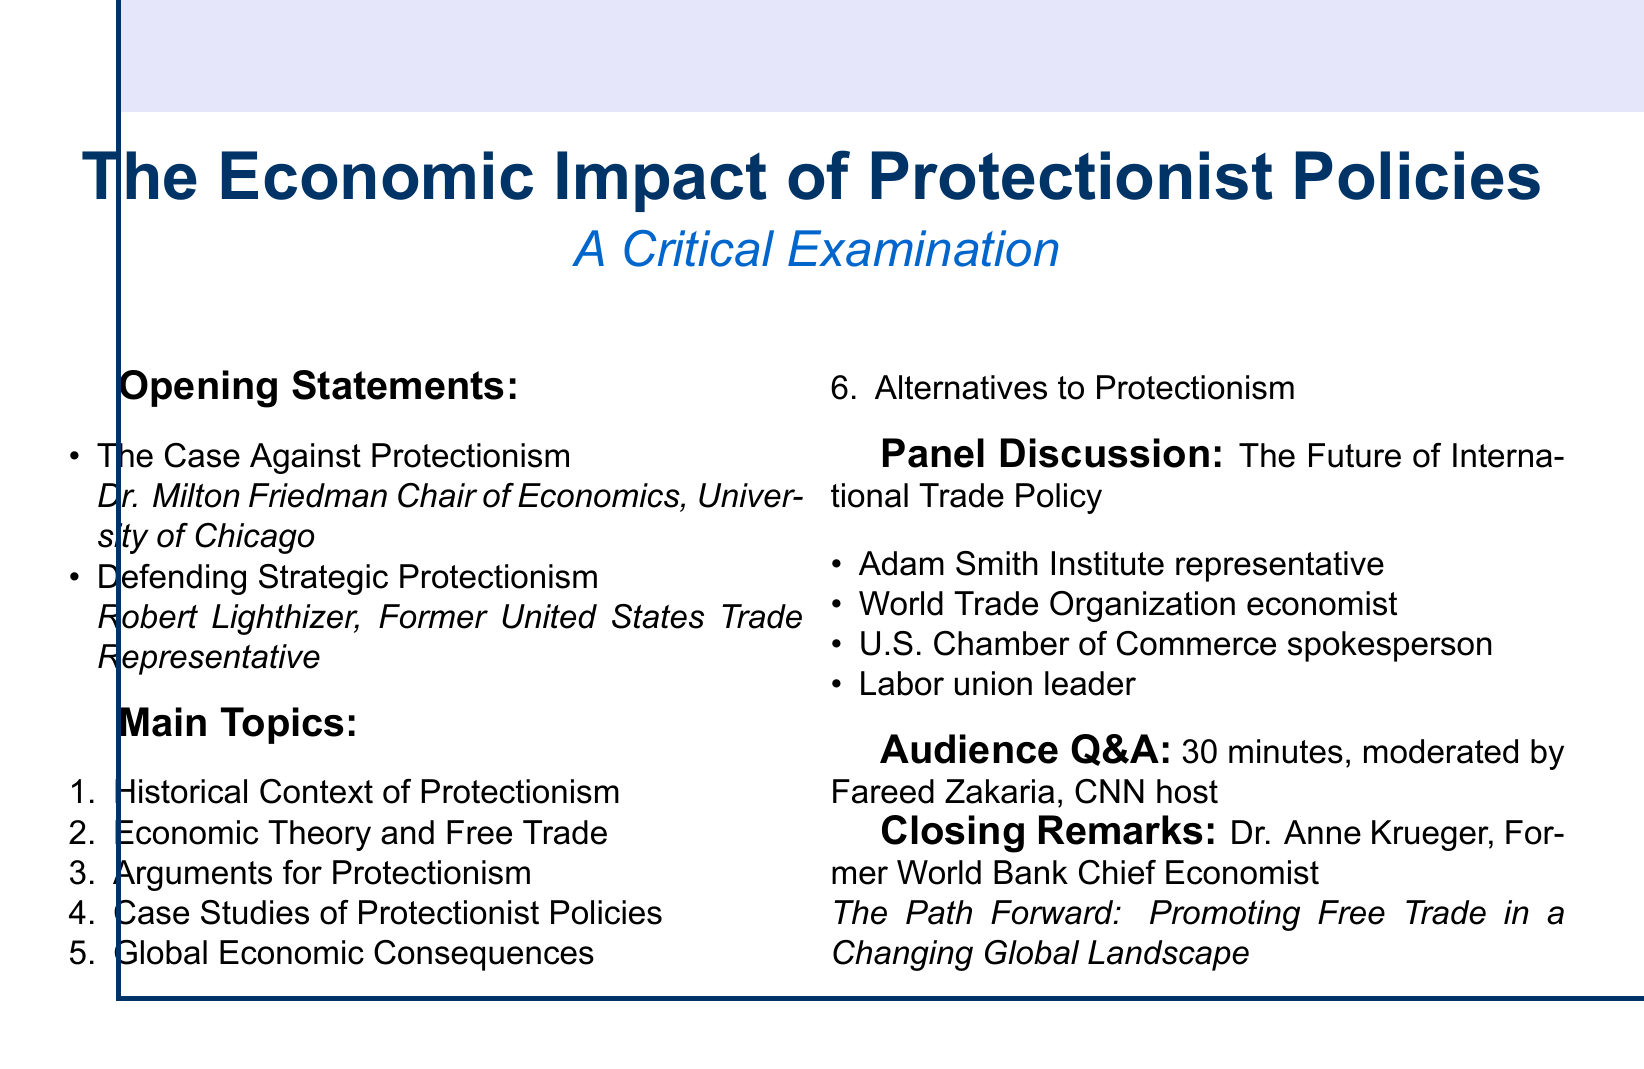What is the title of the debate? The title of the debate is specified at the beginning of the document, which highlights the topic of discussion.
Answer: The Economic Impact of Protectionist Policies: A Critical Examination Who is the speaker for "The Case Against Protectionism"? The document clearly lists the speakers for the opening statements, identifying who presents which case.
Answer: Dr. Milton Friedman Chair of Economics, University of Chicago What is one of the subtopics under "Economic Theory and Free Trade"? The document outlines various subtopics, demonstrating key areas of focus within the broader topic.
Answer: The deadweight loss of tariffs How many panelists are there in the discussion? The document mentions the participants in the panel discussion, allowing a quick count of those involved.
Answer: Four What is the duration of the Audience Q&A? The document provides specific time allocations for different sections, including the audience Q&A portion.
Answer: 30 minutes Who provides the closing remarks? The document states who will give the closing remarks, highlighting their credentials and topic.
Answer: Dr. Anne Krueger, Former World Bank Chief Economist What is an alternative to protectionism mentioned in the agenda? The document lists various alternatives, demonstrating possible solutions to the issues discussed.
Answer: Investment in education and workforce development What year does the Smoot-Hawley Tariff Act relate to? The document includes historical references, pinpointing significant years in trade history.
Answer: 1930 What organization's economist is included in the panel discussion? The document specifies notable representatives participating in the panel discussion, showcasing the diversity of views.
Answer: World Trade Organization economist 